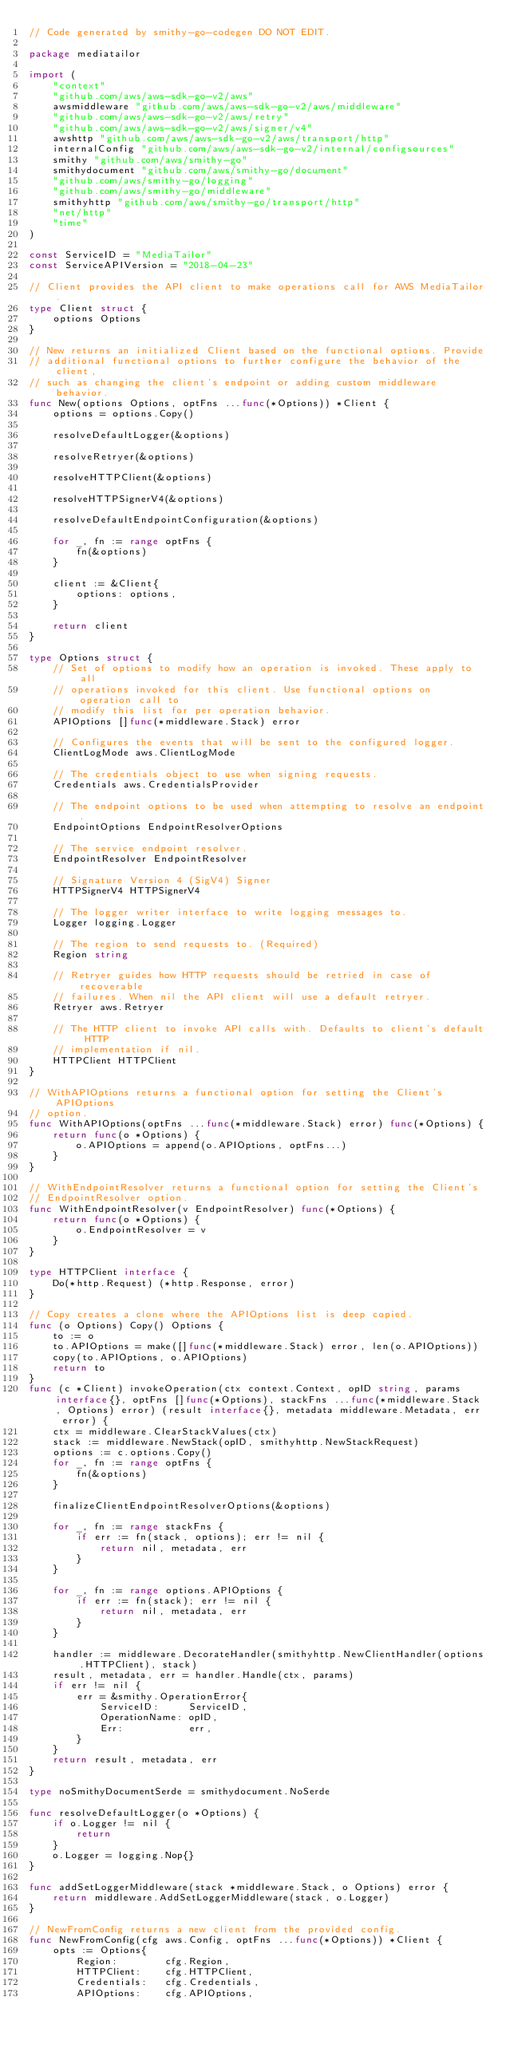Convert code to text. <code><loc_0><loc_0><loc_500><loc_500><_Go_>// Code generated by smithy-go-codegen DO NOT EDIT.

package mediatailor

import (
	"context"
	"github.com/aws/aws-sdk-go-v2/aws"
	awsmiddleware "github.com/aws/aws-sdk-go-v2/aws/middleware"
	"github.com/aws/aws-sdk-go-v2/aws/retry"
	"github.com/aws/aws-sdk-go-v2/aws/signer/v4"
	awshttp "github.com/aws/aws-sdk-go-v2/aws/transport/http"
	internalConfig "github.com/aws/aws-sdk-go-v2/internal/configsources"
	smithy "github.com/aws/smithy-go"
	smithydocument "github.com/aws/smithy-go/document"
	"github.com/aws/smithy-go/logging"
	"github.com/aws/smithy-go/middleware"
	smithyhttp "github.com/aws/smithy-go/transport/http"
	"net/http"
	"time"
)

const ServiceID = "MediaTailor"
const ServiceAPIVersion = "2018-04-23"

// Client provides the API client to make operations call for AWS MediaTailor.
type Client struct {
	options Options
}

// New returns an initialized Client based on the functional options. Provide
// additional functional options to further configure the behavior of the client,
// such as changing the client's endpoint or adding custom middleware behavior.
func New(options Options, optFns ...func(*Options)) *Client {
	options = options.Copy()

	resolveDefaultLogger(&options)

	resolveRetryer(&options)

	resolveHTTPClient(&options)

	resolveHTTPSignerV4(&options)

	resolveDefaultEndpointConfiguration(&options)

	for _, fn := range optFns {
		fn(&options)
	}

	client := &Client{
		options: options,
	}

	return client
}

type Options struct {
	// Set of options to modify how an operation is invoked. These apply to all
	// operations invoked for this client. Use functional options on operation call to
	// modify this list for per operation behavior.
	APIOptions []func(*middleware.Stack) error

	// Configures the events that will be sent to the configured logger.
	ClientLogMode aws.ClientLogMode

	// The credentials object to use when signing requests.
	Credentials aws.CredentialsProvider

	// The endpoint options to be used when attempting to resolve an endpoint.
	EndpointOptions EndpointResolverOptions

	// The service endpoint resolver.
	EndpointResolver EndpointResolver

	// Signature Version 4 (SigV4) Signer
	HTTPSignerV4 HTTPSignerV4

	// The logger writer interface to write logging messages to.
	Logger logging.Logger

	// The region to send requests to. (Required)
	Region string

	// Retryer guides how HTTP requests should be retried in case of recoverable
	// failures. When nil the API client will use a default retryer.
	Retryer aws.Retryer

	// The HTTP client to invoke API calls with. Defaults to client's default HTTP
	// implementation if nil.
	HTTPClient HTTPClient
}

// WithAPIOptions returns a functional option for setting the Client's APIOptions
// option.
func WithAPIOptions(optFns ...func(*middleware.Stack) error) func(*Options) {
	return func(o *Options) {
		o.APIOptions = append(o.APIOptions, optFns...)
	}
}

// WithEndpointResolver returns a functional option for setting the Client's
// EndpointResolver option.
func WithEndpointResolver(v EndpointResolver) func(*Options) {
	return func(o *Options) {
		o.EndpointResolver = v
	}
}

type HTTPClient interface {
	Do(*http.Request) (*http.Response, error)
}

// Copy creates a clone where the APIOptions list is deep copied.
func (o Options) Copy() Options {
	to := o
	to.APIOptions = make([]func(*middleware.Stack) error, len(o.APIOptions))
	copy(to.APIOptions, o.APIOptions)
	return to
}
func (c *Client) invokeOperation(ctx context.Context, opID string, params interface{}, optFns []func(*Options), stackFns ...func(*middleware.Stack, Options) error) (result interface{}, metadata middleware.Metadata, err error) {
	ctx = middleware.ClearStackValues(ctx)
	stack := middleware.NewStack(opID, smithyhttp.NewStackRequest)
	options := c.options.Copy()
	for _, fn := range optFns {
		fn(&options)
	}

	finalizeClientEndpointResolverOptions(&options)

	for _, fn := range stackFns {
		if err := fn(stack, options); err != nil {
			return nil, metadata, err
		}
	}

	for _, fn := range options.APIOptions {
		if err := fn(stack); err != nil {
			return nil, metadata, err
		}
	}

	handler := middleware.DecorateHandler(smithyhttp.NewClientHandler(options.HTTPClient), stack)
	result, metadata, err = handler.Handle(ctx, params)
	if err != nil {
		err = &smithy.OperationError{
			ServiceID:     ServiceID,
			OperationName: opID,
			Err:           err,
		}
	}
	return result, metadata, err
}

type noSmithyDocumentSerde = smithydocument.NoSerde

func resolveDefaultLogger(o *Options) {
	if o.Logger != nil {
		return
	}
	o.Logger = logging.Nop{}
}

func addSetLoggerMiddleware(stack *middleware.Stack, o Options) error {
	return middleware.AddSetLoggerMiddleware(stack, o.Logger)
}

// NewFromConfig returns a new client from the provided config.
func NewFromConfig(cfg aws.Config, optFns ...func(*Options)) *Client {
	opts := Options{
		Region:        cfg.Region,
		HTTPClient:    cfg.HTTPClient,
		Credentials:   cfg.Credentials,
		APIOptions:    cfg.APIOptions,</code> 